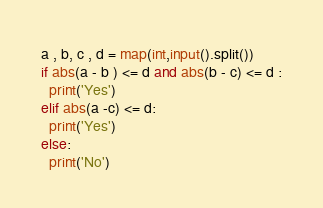Convert code to text. <code><loc_0><loc_0><loc_500><loc_500><_Python_>a , b, c , d = map(int,input().split())
if abs(a - b ) <= d and abs(b - c) <= d :
  print('Yes')
elif abs(a -c) <= d:
  print('Yes')
else:
  print('No')
</code> 